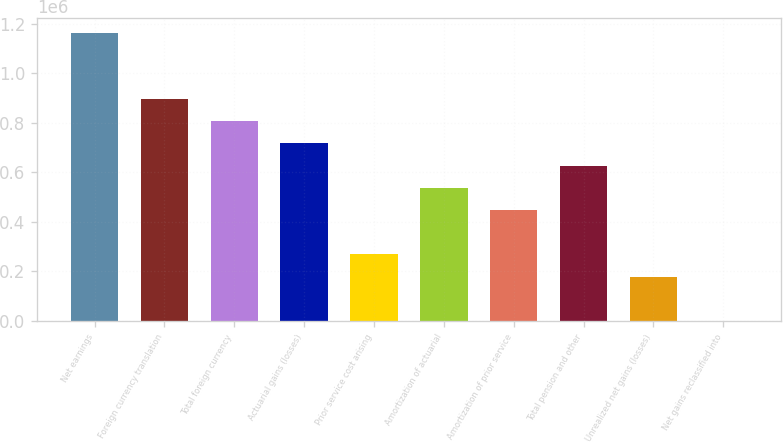Convert chart. <chart><loc_0><loc_0><loc_500><loc_500><bar_chart><fcel>Net earnings<fcel>Foreign currency translation<fcel>Total foreign currency<fcel>Actuarial gains (losses)<fcel>Prior service cost arising<fcel>Amortization of actuarial<fcel>Amortization of prior service<fcel>Total pension and other<fcel>Unrealized net gains (losses)<fcel>Net gains reclassified into<nl><fcel>1.16378e+06<fcel>895243<fcel>805731<fcel>716219<fcel>268660<fcel>537195<fcel>447684<fcel>626707<fcel>179148<fcel>124<nl></chart> 